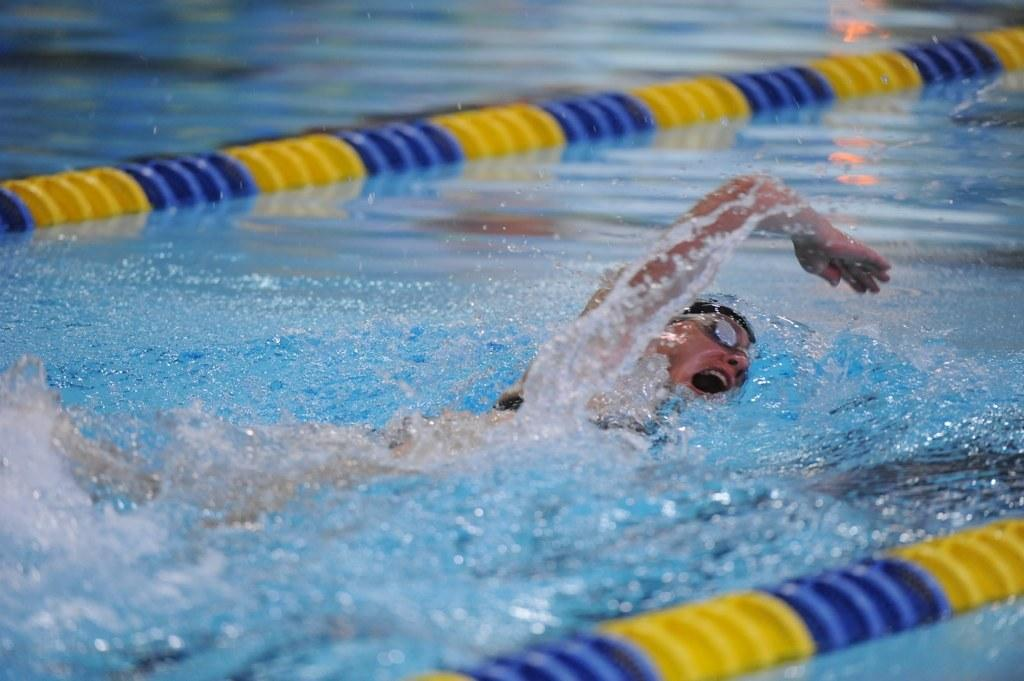Who is present in the image? There is a person in the image. What is the person doing in the image? The person is swimming. How many toads can be seen swimming alongside the person in the image? There are no toads present in the image; only a person is swimming. What type of horses are visible in the image? There are no horses present in the image; the person is swimming alone. 